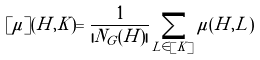<formula> <loc_0><loc_0><loc_500><loc_500>[ \mu ] ( H , K ) = \frac { 1 } { | N _ { G } ( H ) | } \sum _ { L \in [ K ] } \mu ( H , L )</formula> 